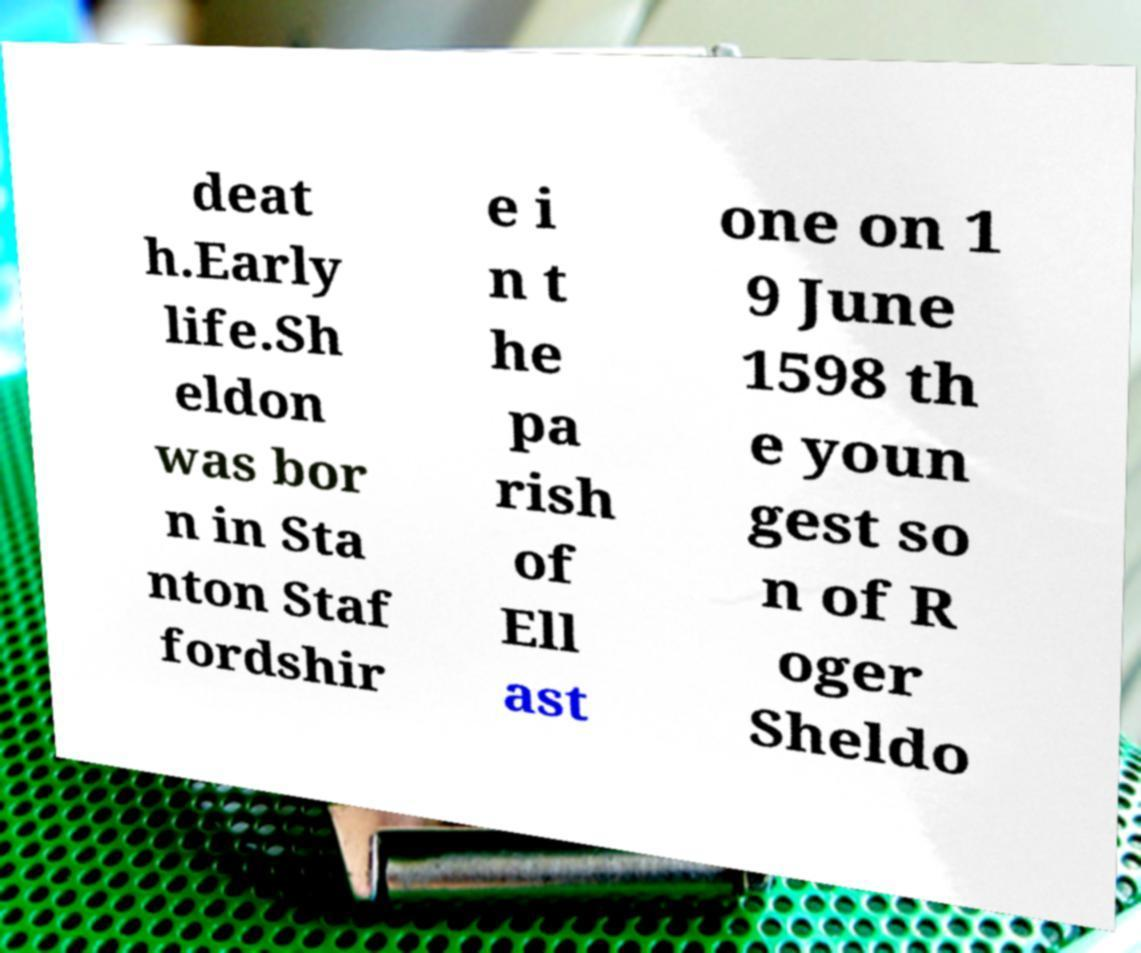Could you assist in decoding the text presented in this image and type it out clearly? deat h.Early life.Sh eldon was bor n in Sta nton Staf fordshir e i n t he pa rish of Ell ast one on 1 9 June 1598 th e youn gest so n of R oger Sheldo 